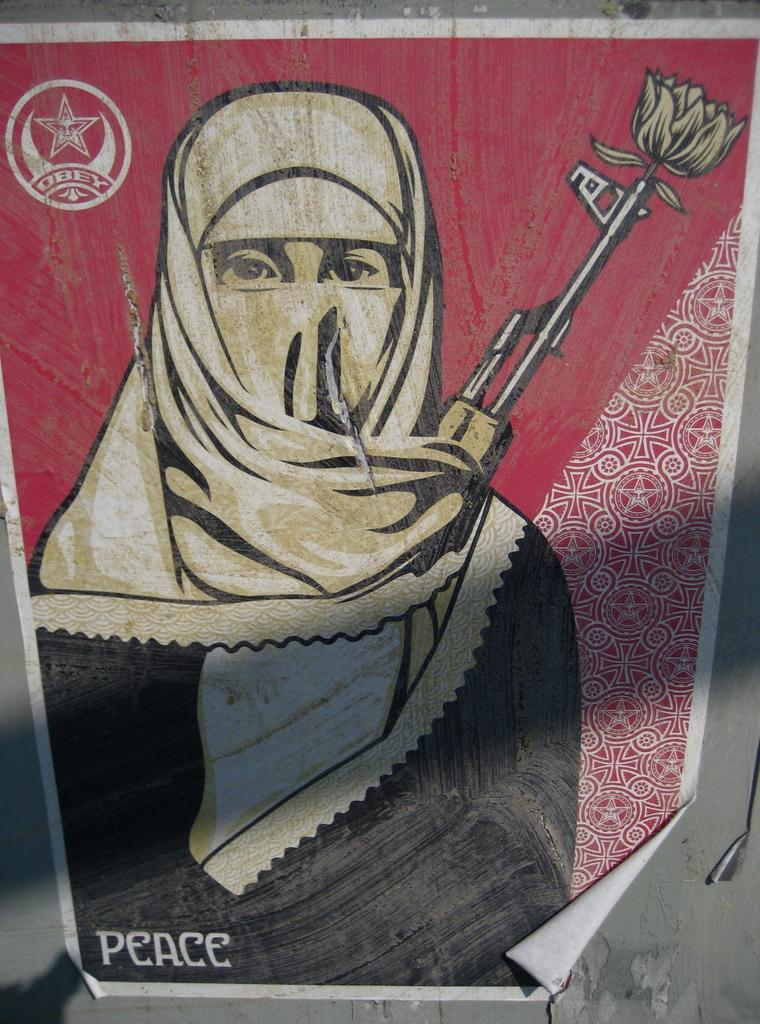What is attached to the wall in the image? There is a poster in the image that is stuck to a wall. What is depicted on the poster? The poster features a person wearing a mask. Is there any additional symbol or element on the poster? Yes, there is a symbol in the top left corner of the poster. What type of humor can be found in the poster's design? There is no information about the poster's design or any humor in the provided facts. 